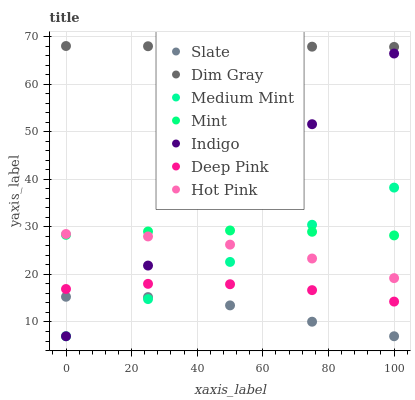Does Slate have the minimum area under the curve?
Answer yes or no. Yes. Does Dim Gray have the maximum area under the curve?
Answer yes or no. Yes. Does Indigo have the minimum area under the curve?
Answer yes or no. No. Does Indigo have the maximum area under the curve?
Answer yes or no. No. Is Dim Gray the smoothest?
Answer yes or no. Yes. Is Slate the roughest?
Answer yes or no. Yes. Is Indigo the smoothest?
Answer yes or no. No. Is Indigo the roughest?
Answer yes or no. No. Does Medium Mint have the lowest value?
Answer yes or no. Yes. Does Dim Gray have the lowest value?
Answer yes or no. No. Does Dim Gray have the highest value?
Answer yes or no. Yes. Does Indigo have the highest value?
Answer yes or no. No. Is Deep Pink less than Dim Gray?
Answer yes or no. Yes. Is Mint greater than Slate?
Answer yes or no. Yes. Does Indigo intersect Mint?
Answer yes or no. Yes. Is Indigo less than Mint?
Answer yes or no. No. Is Indigo greater than Mint?
Answer yes or no. No. Does Deep Pink intersect Dim Gray?
Answer yes or no. No. 